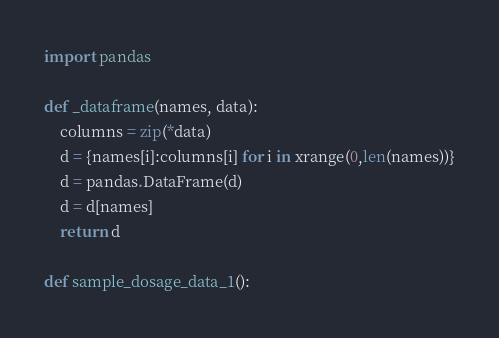Convert code to text. <code><loc_0><loc_0><loc_500><loc_500><_Python_>import pandas

def _dataframe(names, data):
    columns = zip(*data)
    d = {names[i]:columns[i] for i in xrange(0,len(names))}
    d = pandas.DataFrame(d)
    d = d[names]
    return d

def sample_dosage_data_1():</code> 